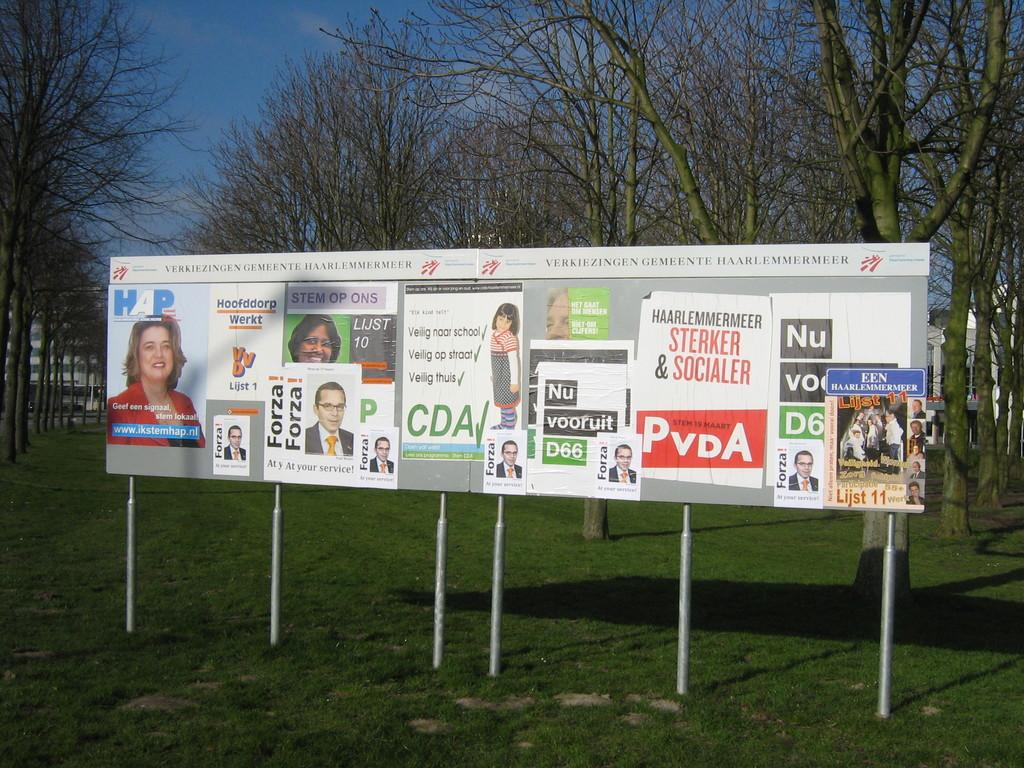What names are advertised on the white poster with red writing?
Ensure brevity in your answer.  Sterker & socialer. 